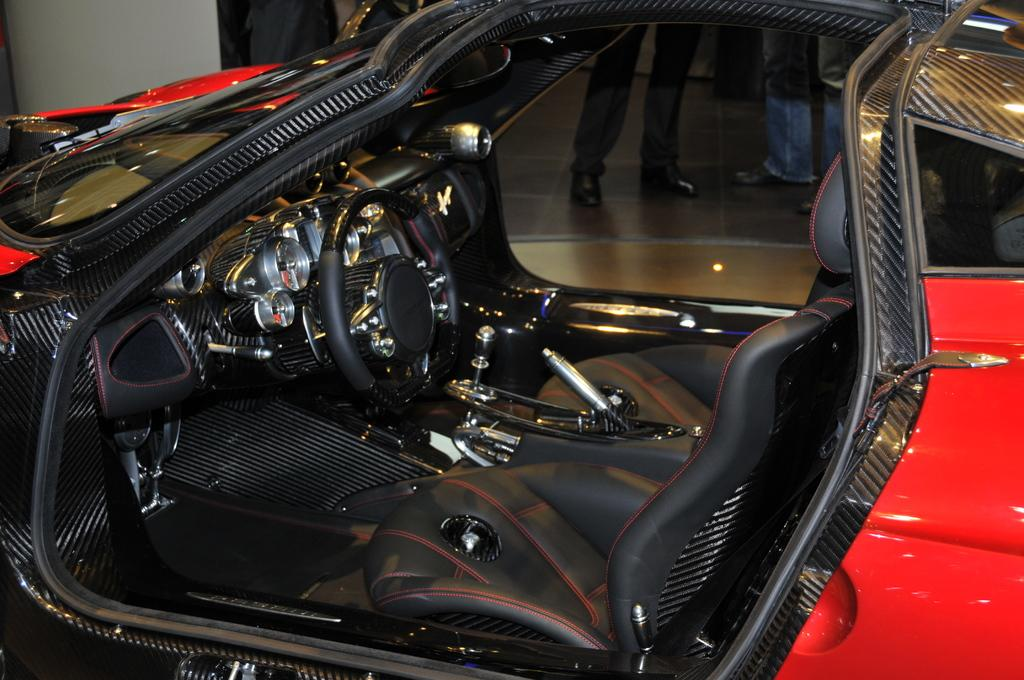What is the main subject of the image? There is a vehicle in the image. What is the color of the vehicle? The vehicle is red in color. What can be seen in the background of the image? There are people standing in the background of the image. What surface are the people standing on? The people are standing on the floor. What type of mint is growing near the vehicle in the image? There is no mint present in the image; it only features a red vehicle and people standing in the background. 